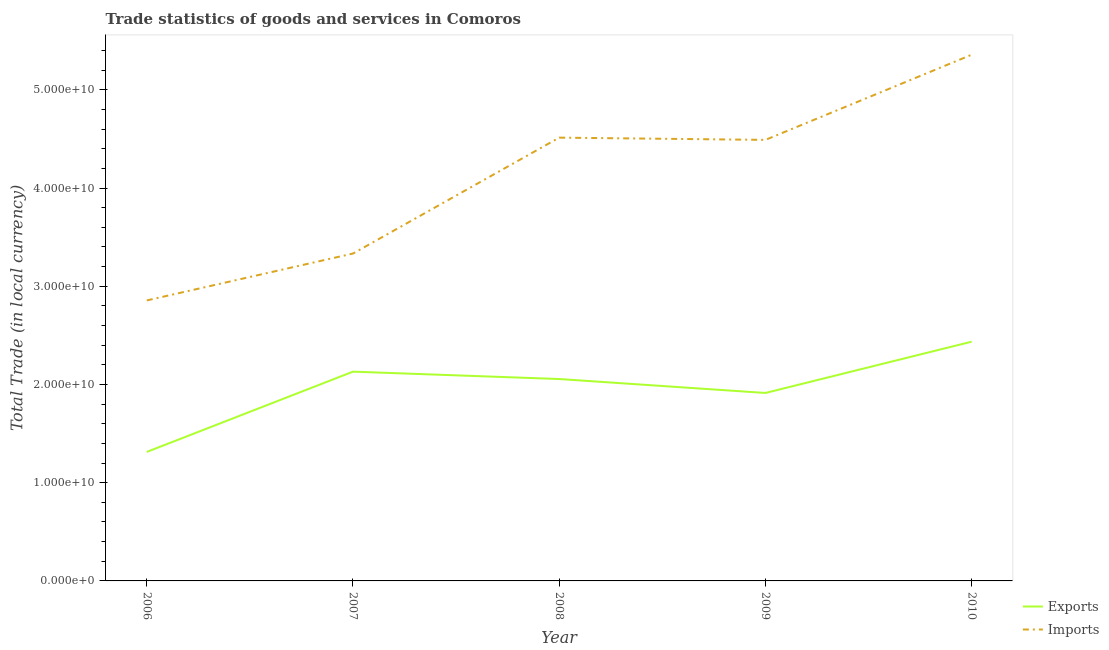Does the line corresponding to imports of goods and services intersect with the line corresponding to export of goods and services?
Provide a succinct answer. No. Is the number of lines equal to the number of legend labels?
Your answer should be very brief. Yes. What is the export of goods and services in 2007?
Your response must be concise. 2.13e+1. Across all years, what is the maximum imports of goods and services?
Ensure brevity in your answer.  5.36e+1. Across all years, what is the minimum imports of goods and services?
Offer a terse response. 2.86e+1. In which year was the export of goods and services maximum?
Give a very brief answer. 2010. What is the total imports of goods and services in the graph?
Give a very brief answer. 2.06e+11. What is the difference between the imports of goods and services in 2007 and that in 2008?
Offer a very short reply. -1.18e+1. What is the difference between the export of goods and services in 2007 and the imports of goods and services in 2010?
Offer a very short reply. -3.23e+1. What is the average imports of goods and services per year?
Provide a short and direct response. 4.11e+1. In the year 2010, what is the difference between the imports of goods and services and export of goods and services?
Your answer should be compact. 2.92e+1. In how many years, is the imports of goods and services greater than 30000000000 LCU?
Offer a terse response. 4. What is the ratio of the imports of goods and services in 2006 to that in 2007?
Provide a succinct answer. 0.86. Is the difference between the imports of goods and services in 2006 and 2009 greater than the difference between the export of goods and services in 2006 and 2009?
Ensure brevity in your answer.  No. What is the difference between the highest and the second highest imports of goods and services?
Ensure brevity in your answer.  8.44e+09. What is the difference between the highest and the lowest imports of goods and services?
Your response must be concise. 2.50e+1. In how many years, is the imports of goods and services greater than the average imports of goods and services taken over all years?
Give a very brief answer. 3. Is the sum of the export of goods and services in 2006 and 2007 greater than the maximum imports of goods and services across all years?
Keep it short and to the point. No. Does the export of goods and services monotonically increase over the years?
Make the answer very short. No. Is the export of goods and services strictly less than the imports of goods and services over the years?
Ensure brevity in your answer.  Yes. How many lines are there?
Offer a terse response. 2. What is the difference between two consecutive major ticks on the Y-axis?
Keep it short and to the point. 1.00e+1. How many legend labels are there?
Provide a succinct answer. 2. How are the legend labels stacked?
Your response must be concise. Vertical. What is the title of the graph?
Offer a terse response. Trade statistics of goods and services in Comoros. What is the label or title of the X-axis?
Offer a terse response. Year. What is the label or title of the Y-axis?
Make the answer very short. Total Trade (in local currency). What is the Total Trade (in local currency) of Exports in 2006?
Ensure brevity in your answer.  1.31e+1. What is the Total Trade (in local currency) of Imports in 2006?
Offer a terse response. 2.86e+1. What is the Total Trade (in local currency) of Exports in 2007?
Offer a terse response. 2.13e+1. What is the Total Trade (in local currency) in Imports in 2007?
Your response must be concise. 3.33e+1. What is the Total Trade (in local currency) in Exports in 2008?
Ensure brevity in your answer.  2.06e+1. What is the Total Trade (in local currency) of Imports in 2008?
Make the answer very short. 4.51e+1. What is the Total Trade (in local currency) in Exports in 2009?
Provide a succinct answer. 1.91e+1. What is the Total Trade (in local currency) in Imports in 2009?
Make the answer very short. 4.49e+1. What is the Total Trade (in local currency) in Exports in 2010?
Make the answer very short. 2.44e+1. What is the Total Trade (in local currency) of Imports in 2010?
Your answer should be very brief. 5.36e+1. Across all years, what is the maximum Total Trade (in local currency) of Exports?
Your answer should be compact. 2.44e+1. Across all years, what is the maximum Total Trade (in local currency) in Imports?
Your answer should be compact. 5.36e+1. Across all years, what is the minimum Total Trade (in local currency) in Exports?
Offer a terse response. 1.31e+1. Across all years, what is the minimum Total Trade (in local currency) in Imports?
Give a very brief answer. 2.86e+1. What is the total Total Trade (in local currency) in Exports in the graph?
Keep it short and to the point. 9.85e+1. What is the total Total Trade (in local currency) of Imports in the graph?
Your answer should be very brief. 2.06e+11. What is the difference between the Total Trade (in local currency) of Exports in 2006 and that in 2007?
Ensure brevity in your answer.  -8.17e+09. What is the difference between the Total Trade (in local currency) of Imports in 2006 and that in 2007?
Provide a short and direct response. -4.77e+09. What is the difference between the Total Trade (in local currency) of Exports in 2006 and that in 2008?
Your answer should be compact. -7.42e+09. What is the difference between the Total Trade (in local currency) in Imports in 2006 and that in 2008?
Provide a succinct answer. -1.66e+1. What is the difference between the Total Trade (in local currency) in Exports in 2006 and that in 2009?
Ensure brevity in your answer.  -6.00e+09. What is the difference between the Total Trade (in local currency) of Imports in 2006 and that in 2009?
Ensure brevity in your answer.  -1.63e+1. What is the difference between the Total Trade (in local currency) in Exports in 2006 and that in 2010?
Offer a very short reply. -1.12e+1. What is the difference between the Total Trade (in local currency) of Imports in 2006 and that in 2010?
Ensure brevity in your answer.  -2.50e+1. What is the difference between the Total Trade (in local currency) of Exports in 2007 and that in 2008?
Give a very brief answer. 7.52e+08. What is the difference between the Total Trade (in local currency) of Imports in 2007 and that in 2008?
Make the answer very short. -1.18e+1. What is the difference between the Total Trade (in local currency) of Exports in 2007 and that in 2009?
Offer a very short reply. 2.17e+09. What is the difference between the Total Trade (in local currency) in Imports in 2007 and that in 2009?
Give a very brief answer. -1.16e+1. What is the difference between the Total Trade (in local currency) of Exports in 2007 and that in 2010?
Make the answer very short. -3.05e+09. What is the difference between the Total Trade (in local currency) in Imports in 2007 and that in 2010?
Offer a very short reply. -2.02e+1. What is the difference between the Total Trade (in local currency) in Exports in 2008 and that in 2009?
Your answer should be very brief. 1.42e+09. What is the difference between the Total Trade (in local currency) of Imports in 2008 and that in 2009?
Provide a succinct answer. 2.28e+08. What is the difference between the Total Trade (in local currency) in Exports in 2008 and that in 2010?
Your answer should be compact. -3.80e+09. What is the difference between the Total Trade (in local currency) in Imports in 2008 and that in 2010?
Offer a very short reply. -8.44e+09. What is the difference between the Total Trade (in local currency) in Exports in 2009 and that in 2010?
Ensure brevity in your answer.  -5.22e+09. What is the difference between the Total Trade (in local currency) in Imports in 2009 and that in 2010?
Keep it short and to the point. -8.67e+09. What is the difference between the Total Trade (in local currency) in Exports in 2006 and the Total Trade (in local currency) in Imports in 2007?
Make the answer very short. -2.02e+1. What is the difference between the Total Trade (in local currency) in Exports in 2006 and the Total Trade (in local currency) in Imports in 2008?
Keep it short and to the point. -3.20e+1. What is the difference between the Total Trade (in local currency) of Exports in 2006 and the Total Trade (in local currency) of Imports in 2009?
Your answer should be very brief. -3.18e+1. What is the difference between the Total Trade (in local currency) of Exports in 2006 and the Total Trade (in local currency) of Imports in 2010?
Ensure brevity in your answer.  -4.04e+1. What is the difference between the Total Trade (in local currency) of Exports in 2007 and the Total Trade (in local currency) of Imports in 2008?
Offer a very short reply. -2.38e+1. What is the difference between the Total Trade (in local currency) in Exports in 2007 and the Total Trade (in local currency) in Imports in 2009?
Make the answer very short. -2.36e+1. What is the difference between the Total Trade (in local currency) in Exports in 2007 and the Total Trade (in local currency) in Imports in 2010?
Make the answer very short. -3.23e+1. What is the difference between the Total Trade (in local currency) of Exports in 2008 and the Total Trade (in local currency) of Imports in 2009?
Your response must be concise. -2.43e+1. What is the difference between the Total Trade (in local currency) in Exports in 2008 and the Total Trade (in local currency) in Imports in 2010?
Ensure brevity in your answer.  -3.30e+1. What is the difference between the Total Trade (in local currency) in Exports in 2009 and the Total Trade (in local currency) in Imports in 2010?
Your response must be concise. -3.44e+1. What is the average Total Trade (in local currency) in Exports per year?
Offer a very short reply. 1.97e+1. What is the average Total Trade (in local currency) of Imports per year?
Offer a very short reply. 4.11e+1. In the year 2006, what is the difference between the Total Trade (in local currency) in Exports and Total Trade (in local currency) in Imports?
Provide a succinct answer. -1.54e+1. In the year 2007, what is the difference between the Total Trade (in local currency) of Exports and Total Trade (in local currency) of Imports?
Your answer should be very brief. -1.20e+1. In the year 2008, what is the difference between the Total Trade (in local currency) of Exports and Total Trade (in local currency) of Imports?
Provide a short and direct response. -2.46e+1. In the year 2009, what is the difference between the Total Trade (in local currency) of Exports and Total Trade (in local currency) of Imports?
Offer a very short reply. -2.58e+1. In the year 2010, what is the difference between the Total Trade (in local currency) of Exports and Total Trade (in local currency) of Imports?
Your answer should be compact. -2.92e+1. What is the ratio of the Total Trade (in local currency) in Exports in 2006 to that in 2007?
Your response must be concise. 0.62. What is the ratio of the Total Trade (in local currency) in Imports in 2006 to that in 2007?
Make the answer very short. 0.86. What is the ratio of the Total Trade (in local currency) of Exports in 2006 to that in 2008?
Your response must be concise. 0.64. What is the ratio of the Total Trade (in local currency) in Imports in 2006 to that in 2008?
Provide a short and direct response. 0.63. What is the ratio of the Total Trade (in local currency) of Exports in 2006 to that in 2009?
Ensure brevity in your answer.  0.69. What is the ratio of the Total Trade (in local currency) of Imports in 2006 to that in 2009?
Ensure brevity in your answer.  0.64. What is the ratio of the Total Trade (in local currency) in Exports in 2006 to that in 2010?
Your answer should be very brief. 0.54. What is the ratio of the Total Trade (in local currency) of Imports in 2006 to that in 2010?
Your answer should be very brief. 0.53. What is the ratio of the Total Trade (in local currency) of Exports in 2007 to that in 2008?
Give a very brief answer. 1.04. What is the ratio of the Total Trade (in local currency) of Imports in 2007 to that in 2008?
Your answer should be very brief. 0.74. What is the ratio of the Total Trade (in local currency) in Exports in 2007 to that in 2009?
Your response must be concise. 1.11. What is the ratio of the Total Trade (in local currency) of Imports in 2007 to that in 2009?
Your response must be concise. 0.74. What is the ratio of the Total Trade (in local currency) in Exports in 2007 to that in 2010?
Your response must be concise. 0.87. What is the ratio of the Total Trade (in local currency) of Imports in 2007 to that in 2010?
Give a very brief answer. 0.62. What is the ratio of the Total Trade (in local currency) of Exports in 2008 to that in 2009?
Your answer should be very brief. 1.07. What is the ratio of the Total Trade (in local currency) of Imports in 2008 to that in 2009?
Offer a very short reply. 1.01. What is the ratio of the Total Trade (in local currency) in Exports in 2008 to that in 2010?
Your answer should be very brief. 0.84. What is the ratio of the Total Trade (in local currency) in Imports in 2008 to that in 2010?
Your answer should be very brief. 0.84. What is the ratio of the Total Trade (in local currency) in Exports in 2009 to that in 2010?
Ensure brevity in your answer.  0.79. What is the ratio of the Total Trade (in local currency) of Imports in 2009 to that in 2010?
Your answer should be very brief. 0.84. What is the difference between the highest and the second highest Total Trade (in local currency) of Exports?
Your response must be concise. 3.05e+09. What is the difference between the highest and the second highest Total Trade (in local currency) in Imports?
Offer a very short reply. 8.44e+09. What is the difference between the highest and the lowest Total Trade (in local currency) in Exports?
Your answer should be very brief. 1.12e+1. What is the difference between the highest and the lowest Total Trade (in local currency) in Imports?
Provide a succinct answer. 2.50e+1. 